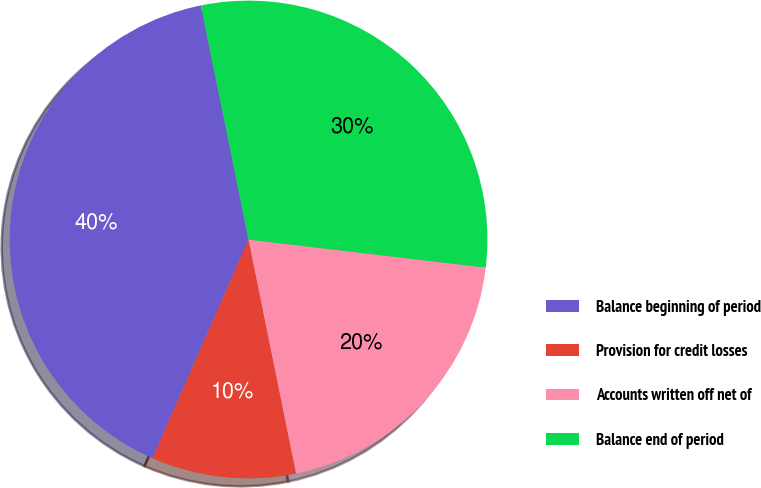<chart> <loc_0><loc_0><loc_500><loc_500><pie_chart><fcel>Balance beginning of period<fcel>Provision for credit losses<fcel>Accounts written off net of<fcel>Balance end of period<nl><fcel>40.22%<fcel>9.78%<fcel>19.93%<fcel>30.07%<nl></chart> 